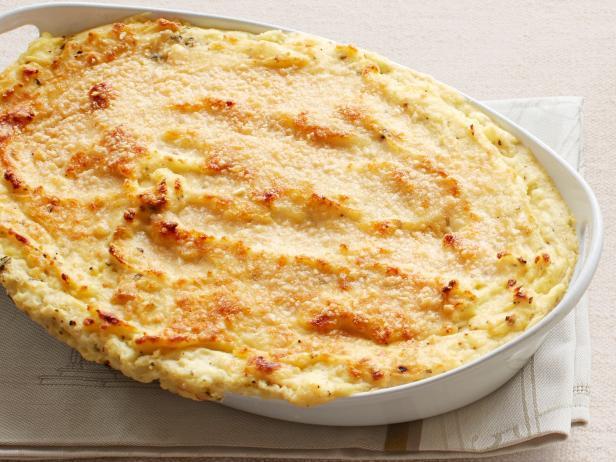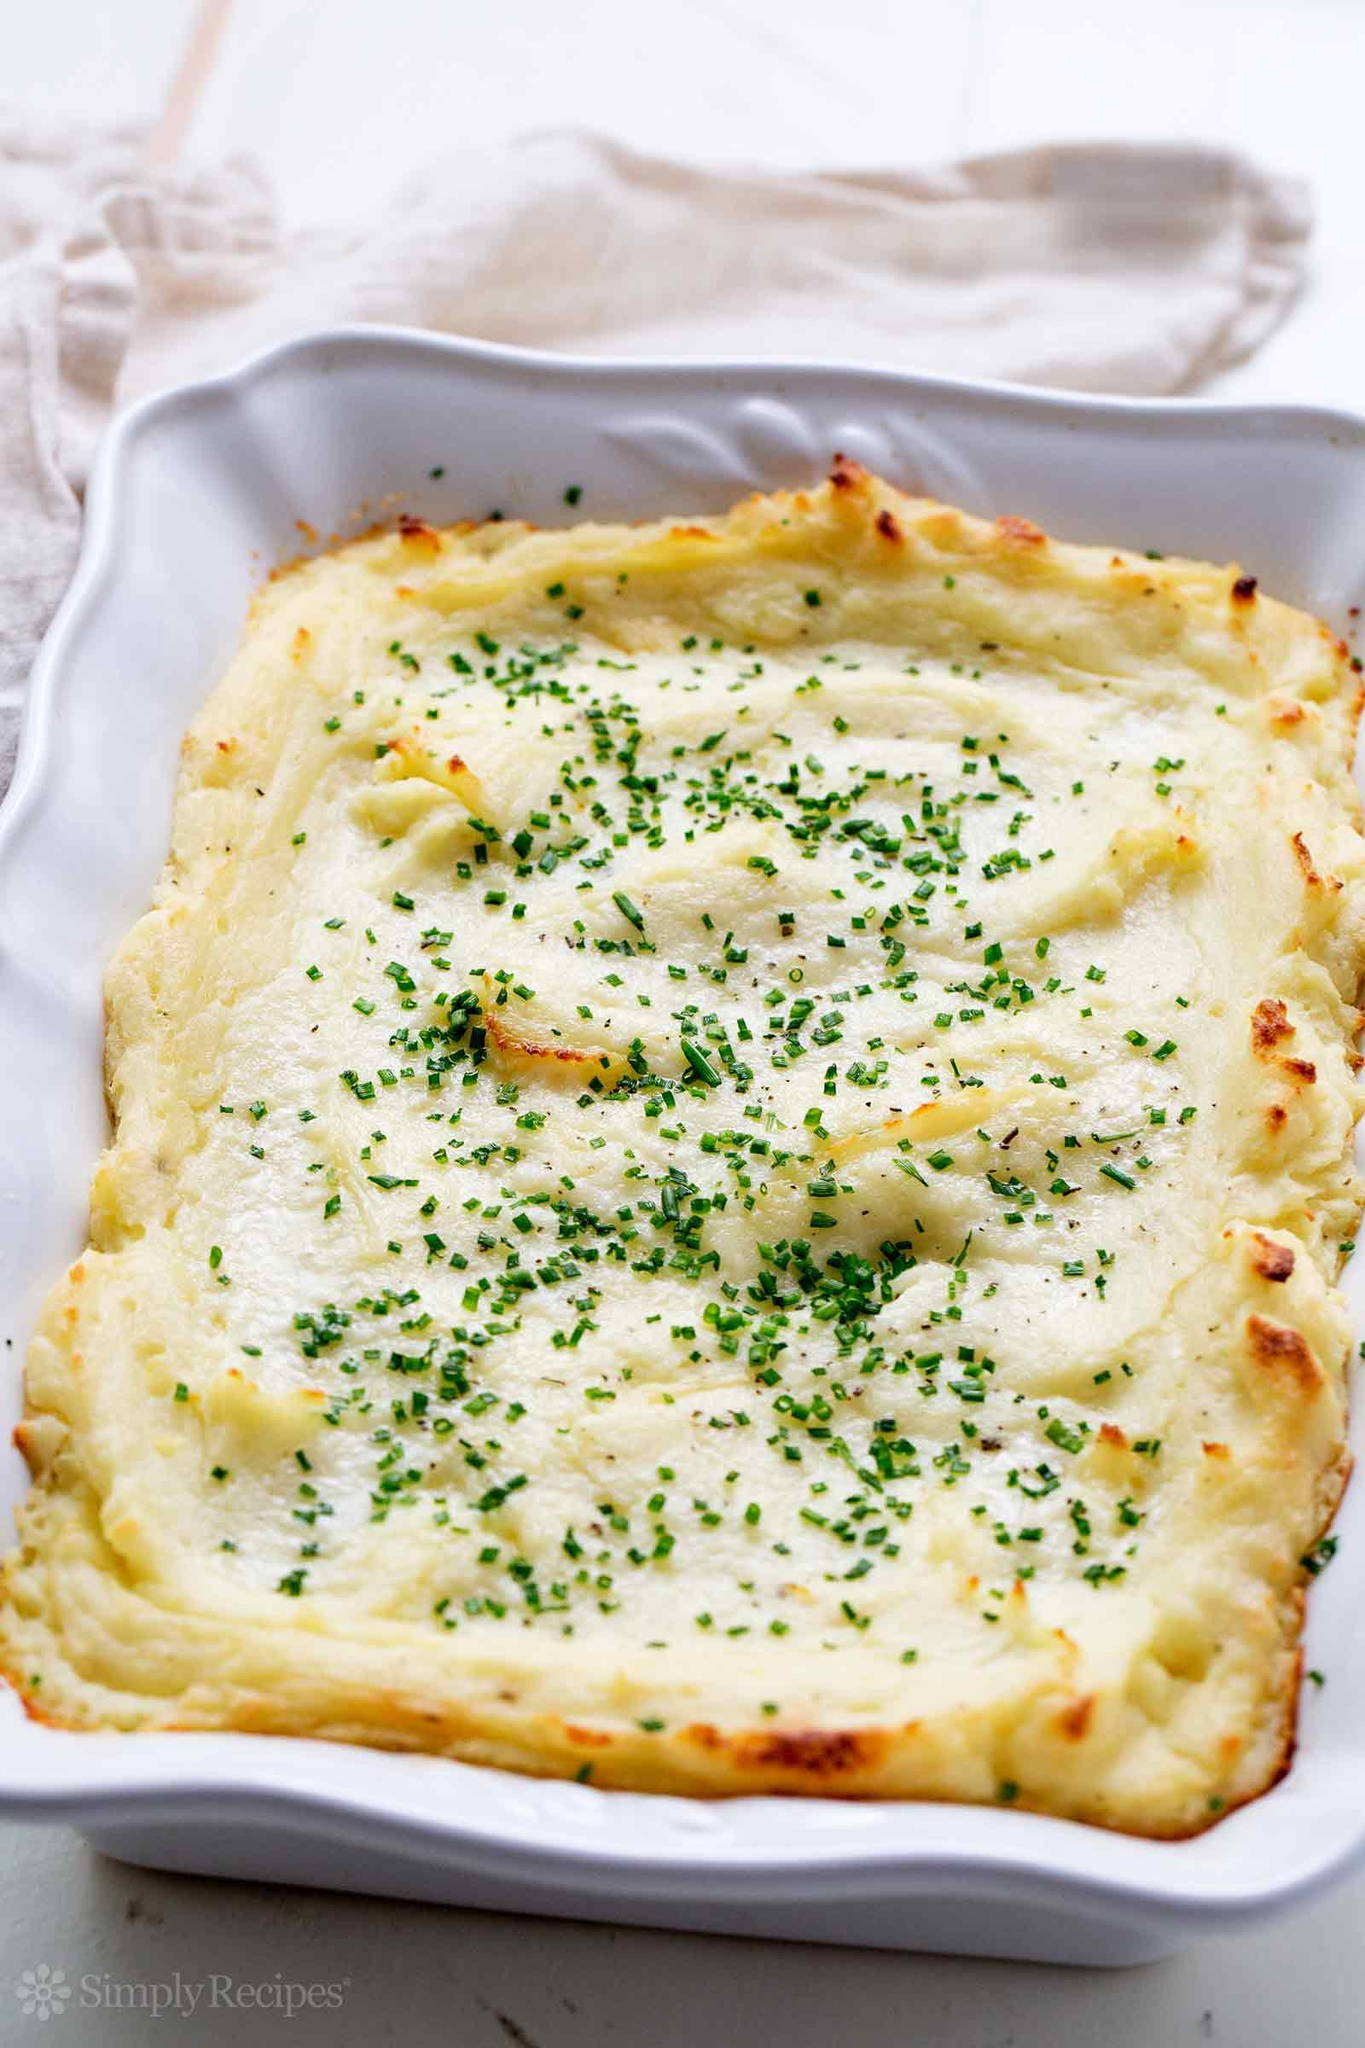The first image is the image on the left, the second image is the image on the right. Considering the images on both sides, is "A casserole is in a white rectangular baking dish with chopped green chives on top." valid? Answer yes or no. Yes. The first image is the image on the left, the second image is the image on the right. Considering the images on both sides, is "the casserole dish on the image in the right side is rectangular and white." valid? Answer yes or no. Yes. 